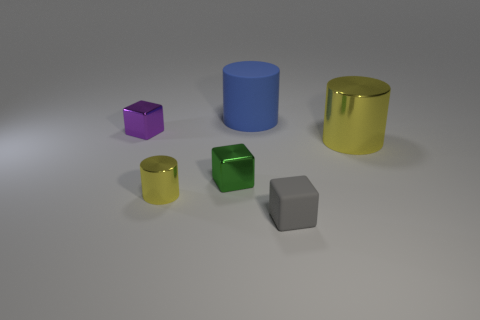There is a gray matte block in front of the small green object; how big is it?
Offer a very short reply. Small. What number of green things are either tiny shiny things or shiny cylinders?
Provide a succinct answer. 1. Are there any green shiny cylinders of the same size as the gray thing?
Provide a succinct answer. No. What is the material of the purple thing that is the same size as the green cube?
Give a very brief answer. Metal. Is the size of the yellow cylinder that is behind the tiny yellow metal thing the same as the metallic cube that is in front of the small purple cube?
Keep it short and to the point. No. What number of objects are small green metal objects or metal things that are right of the gray block?
Provide a short and direct response. 2. Are there any large things of the same shape as the tiny yellow thing?
Offer a terse response. Yes. There is a yellow metal cylinder that is left of the tiny object on the right side of the big matte thing; what size is it?
Offer a terse response. Small. Do the small cylinder and the large metal thing have the same color?
Your answer should be compact. Yes. What number of shiny things are either blue objects or small green cylinders?
Give a very brief answer. 0. 